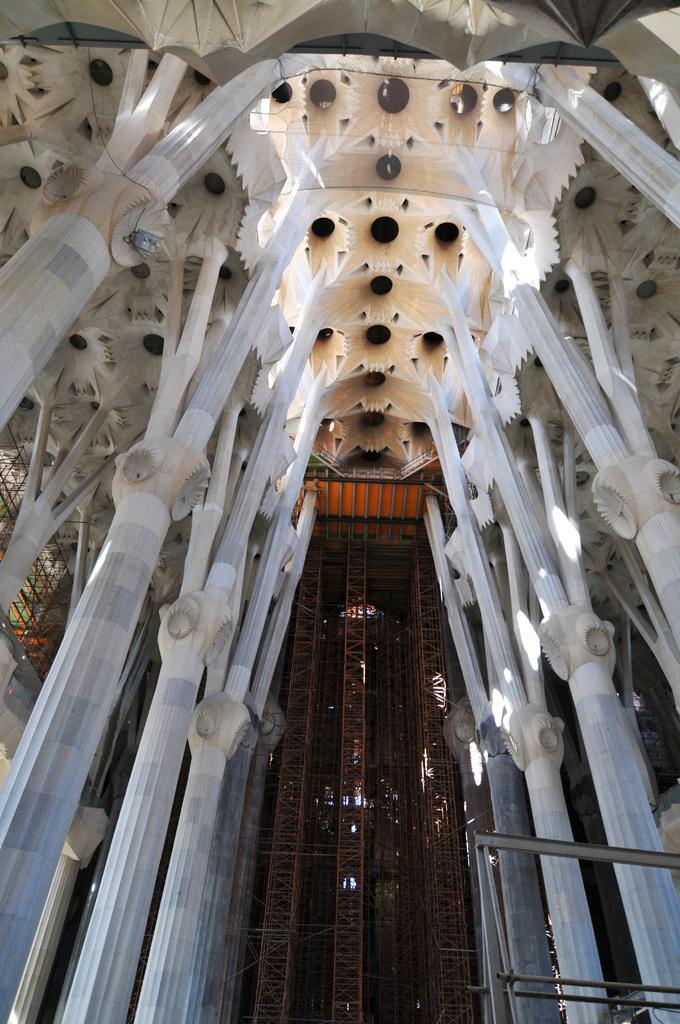In one or two sentences, can you explain what this image depicts? There are few objects which are white in color and there are rods in the background. 